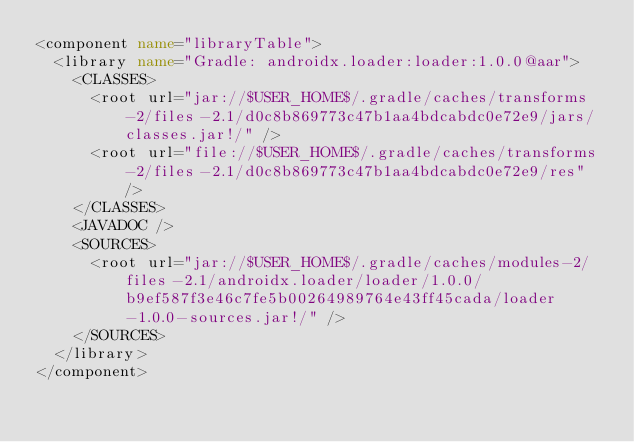<code> <loc_0><loc_0><loc_500><loc_500><_XML_><component name="libraryTable">
  <library name="Gradle: androidx.loader:loader:1.0.0@aar">
    <CLASSES>
      <root url="jar://$USER_HOME$/.gradle/caches/transforms-2/files-2.1/d0c8b869773c47b1aa4bdcabdc0e72e9/jars/classes.jar!/" />
      <root url="file://$USER_HOME$/.gradle/caches/transforms-2/files-2.1/d0c8b869773c47b1aa4bdcabdc0e72e9/res" />
    </CLASSES>
    <JAVADOC />
    <SOURCES>
      <root url="jar://$USER_HOME$/.gradle/caches/modules-2/files-2.1/androidx.loader/loader/1.0.0/b9ef587f3e46c7fe5b00264989764e43ff45cada/loader-1.0.0-sources.jar!/" />
    </SOURCES>
  </library>
</component></code> 